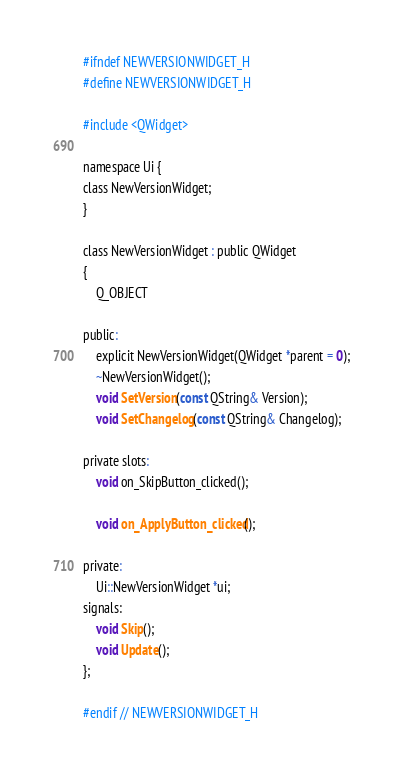<code> <loc_0><loc_0><loc_500><loc_500><_C_>#ifndef NEWVERSIONWIDGET_H
#define NEWVERSIONWIDGET_H

#include <QWidget>

namespace Ui {
class NewVersionWidget;
}

class NewVersionWidget : public QWidget
{
    Q_OBJECT

public:
    explicit NewVersionWidget(QWidget *parent = 0);
    ~NewVersionWidget();
    void SetVersion(const QString& Version);
    void SetChangelog(const QString& Changelog);

private slots:
    void on_SkipButton_clicked();

    void on_ApplyButton_clicked();

private:
    Ui::NewVersionWidget *ui;
signals:
    void Skip();
    void Update();
};

#endif // NEWVERSIONWIDGET_H
</code> 